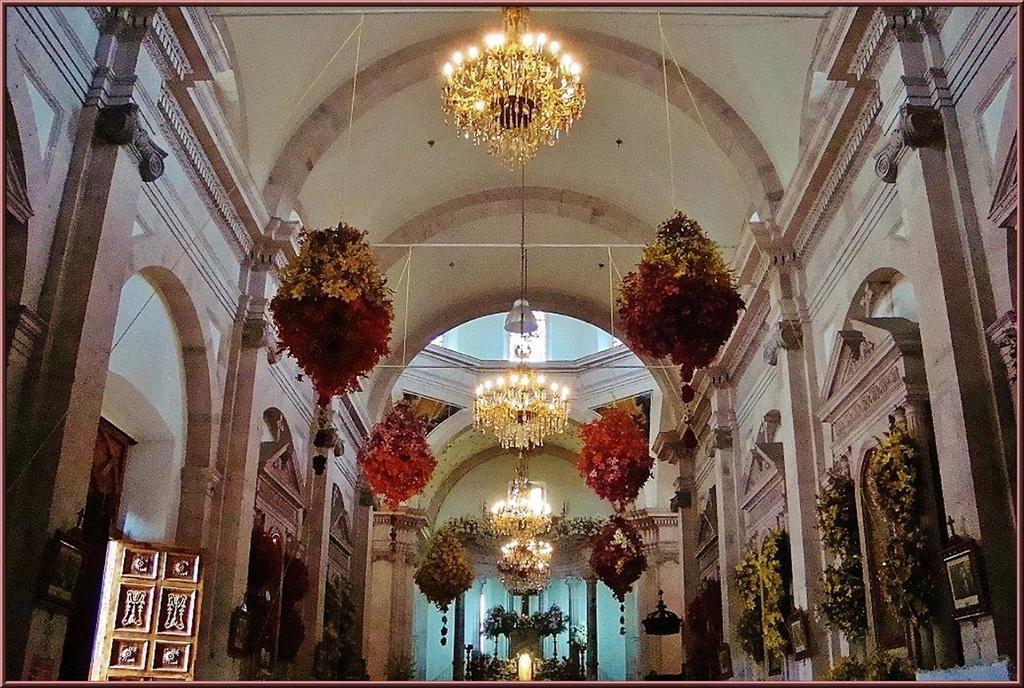Could you give a brief overview of what you see in this image? This image is taken from inside, in this image there is decoration with artificial plants and there are few chandeliers from the ceiling, there are a few frames hanging on the wall. 